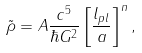<formula> <loc_0><loc_0><loc_500><loc_500>\tilde { \rho } = A \frac { c ^ { 5 } } { \hbar { G } ^ { 2 } } \left [ \frac { l _ { p l } } { a } \right ] ^ { n } ,</formula> 